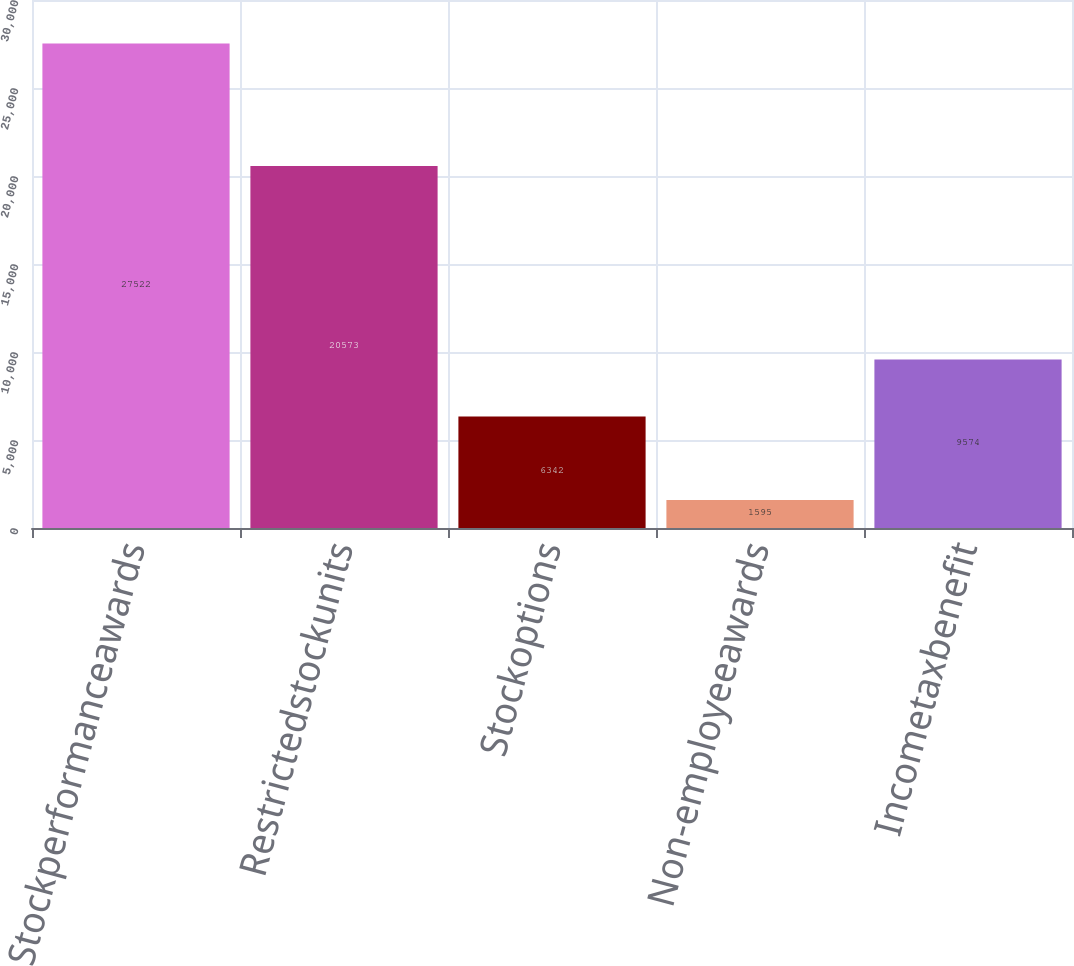<chart> <loc_0><loc_0><loc_500><loc_500><bar_chart><fcel>Stockperformanceawards<fcel>Restrictedstockunits<fcel>Stockoptions<fcel>Non-employeeawards<fcel>Incometaxbenefit<nl><fcel>27522<fcel>20573<fcel>6342<fcel>1595<fcel>9574<nl></chart> 